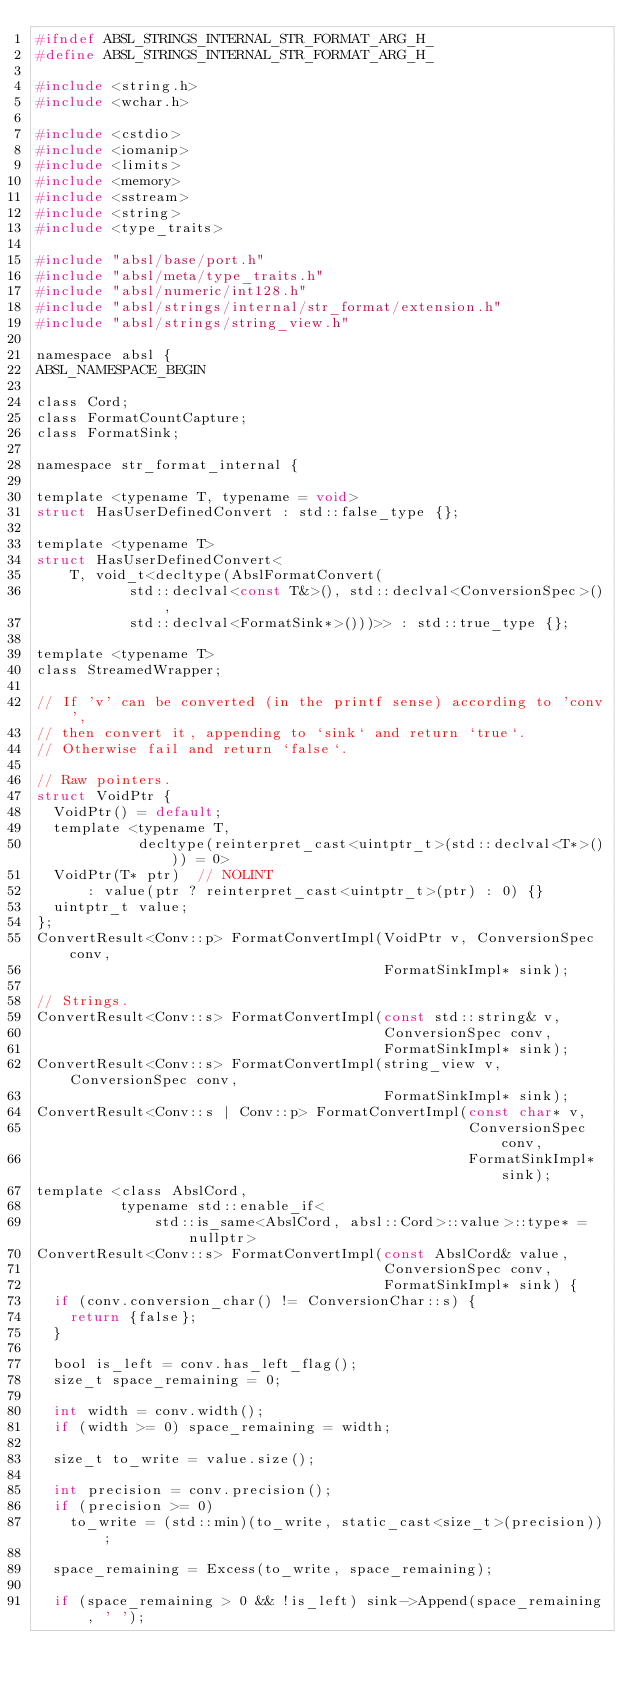Convert code to text. <code><loc_0><loc_0><loc_500><loc_500><_C_>#ifndef ABSL_STRINGS_INTERNAL_STR_FORMAT_ARG_H_
#define ABSL_STRINGS_INTERNAL_STR_FORMAT_ARG_H_

#include <string.h>
#include <wchar.h>

#include <cstdio>
#include <iomanip>
#include <limits>
#include <memory>
#include <sstream>
#include <string>
#include <type_traits>

#include "absl/base/port.h"
#include "absl/meta/type_traits.h"
#include "absl/numeric/int128.h"
#include "absl/strings/internal/str_format/extension.h"
#include "absl/strings/string_view.h"

namespace absl {
ABSL_NAMESPACE_BEGIN

class Cord;
class FormatCountCapture;
class FormatSink;

namespace str_format_internal {

template <typename T, typename = void>
struct HasUserDefinedConvert : std::false_type {};

template <typename T>
struct HasUserDefinedConvert<
    T, void_t<decltype(AbslFormatConvert(
           std::declval<const T&>(), std::declval<ConversionSpec>(),
           std::declval<FormatSink*>()))>> : std::true_type {};

template <typename T>
class StreamedWrapper;

// If 'v' can be converted (in the printf sense) according to 'conv',
// then convert it, appending to `sink` and return `true`.
// Otherwise fail and return `false`.

// Raw pointers.
struct VoidPtr {
  VoidPtr() = default;
  template <typename T,
            decltype(reinterpret_cast<uintptr_t>(std::declval<T*>())) = 0>
  VoidPtr(T* ptr)  // NOLINT
      : value(ptr ? reinterpret_cast<uintptr_t>(ptr) : 0) {}
  uintptr_t value;
};
ConvertResult<Conv::p> FormatConvertImpl(VoidPtr v, ConversionSpec conv,
                                         FormatSinkImpl* sink);

// Strings.
ConvertResult<Conv::s> FormatConvertImpl(const std::string& v,
                                         ConversionSpec conv,
                                         FormatSinkImpl* sink);
ConvertResult<Conv::s> FormatConvertImpl(string_view v, ConversionSpec conv,
                                         FormatSinkImpl* sink);
ConvertResult<Conv::s | Conv::p> FormatConvertImpl(const char* v,
                                                   ConversionSpec conv,
                                                   FormatSinkImpl* sink);
template <class AbslCord,
          typename std::enable_if<
              std::is_same<AbslCord, absl::Cord>::value>::type* = nullptr>
ConvertResult<Conv::s> FormatConvertImpl(const AbslCord& value,
                                         ConversionSpec conv,
                                         FormatSinkImpl* sink) {
  if (conv.conversion_char() != ConversionChar::s) {
    return {false};
  }

  bool is_left = conv.has_left_flag();
  size_t space_remaining = 0;

  int width = conv.width();
  if (width >= 0) space_remaining = width;

  size_t to_write = value.size();

  int precision = conv.precision();
  if (precision >= 0)
    to_write = (std::min)(to_write, static_cast<size_t>(precision));

  space_remaining = Excess(to_write, space_remaining);

  if (space_remaining > 0 && !is_left) sink->Append(space_remaining, ' ');
</code> 